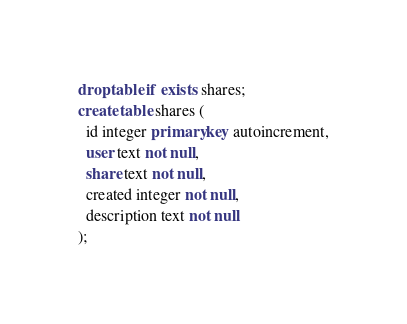Convert code to text. <code><loc_0><loc_0><loc_500><loc_500><_SQL_>drop table if exists shares;
create table shares (
  id integer primary key autoincrement,
  user text not null,
  share text not null,
  created integer not null,
  description text not null
);
</code> 